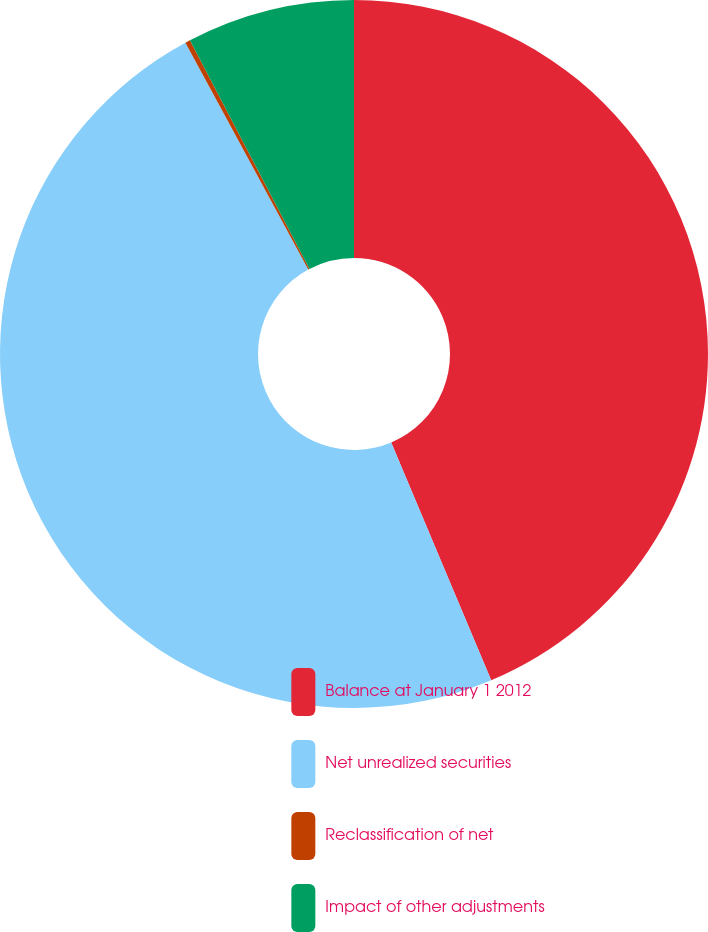Convert chart to OTSL. <chart><loc_0><loc_0><loc_500><loc_500><pie_chart><fcel>Balance at January 1 2012<fcel>Net unrealized securities<fcel>Reclassification of net<fcel>Impact of other adjustments<nl><fcel>43.67%<fcel>48.44%<fcel>0.23%<fcel>7.67%<nl></chart> 